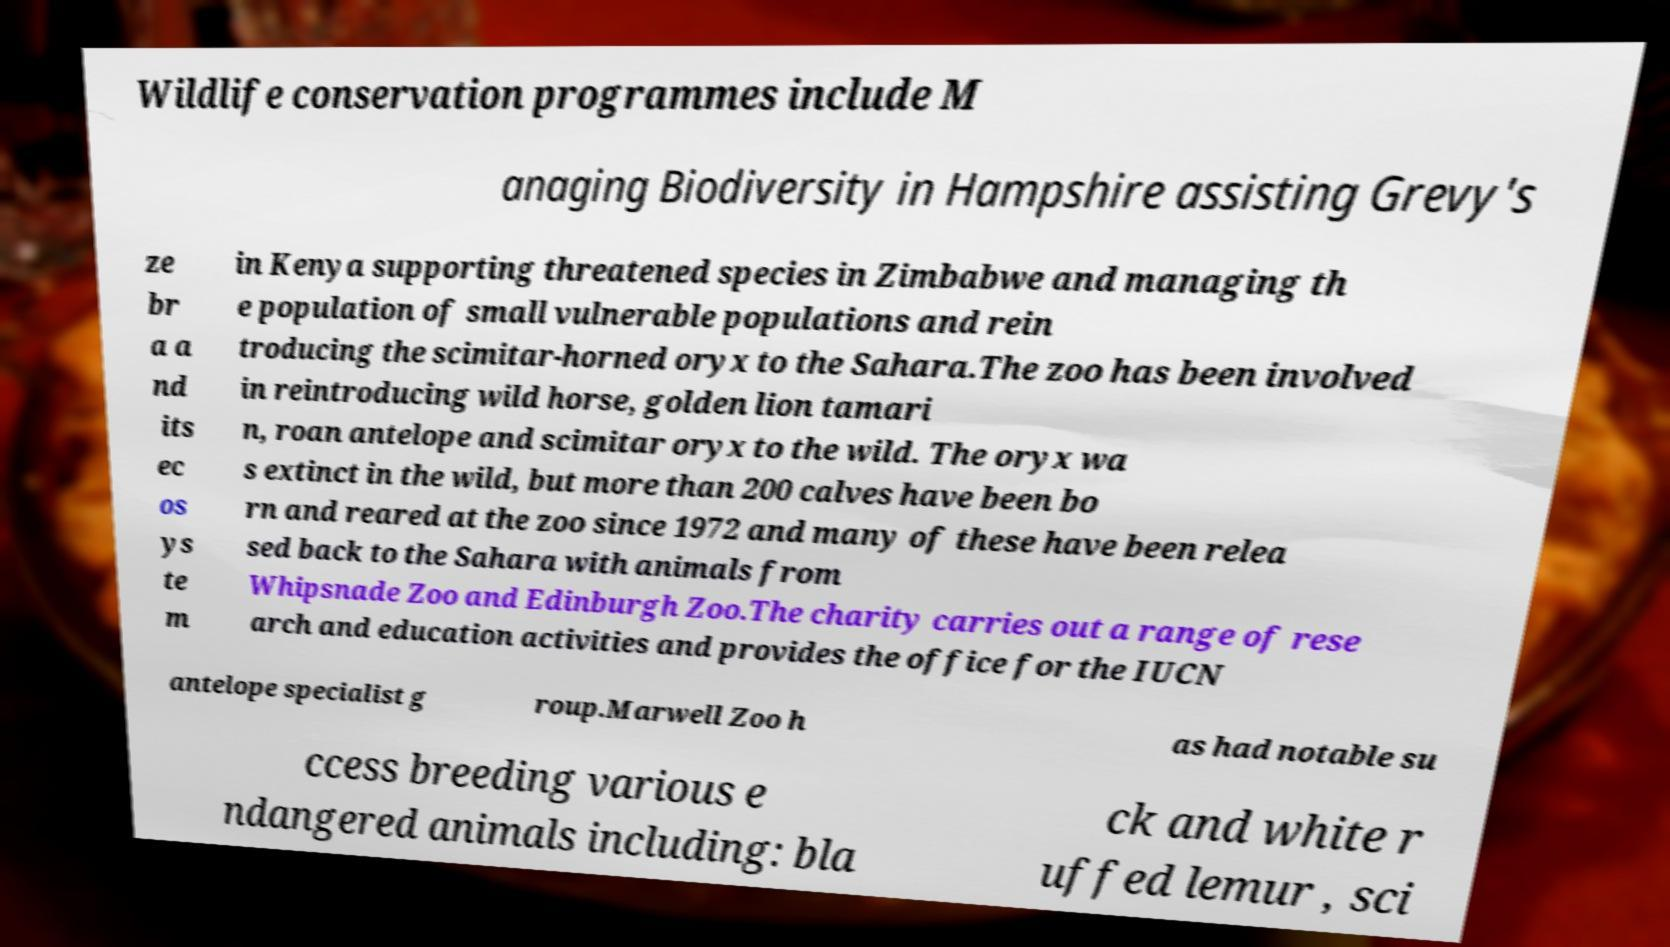Could you assist in decoding the text presented in this image and type it out clearly? Wildlife conservation programmes include M anaging Biodiversity in Hampshire assisting Grevy's ze br a a nd its ec os ys te m in Kenya supporting threatened species in Zimbabwe and managing th e population of small vulnerable populations and rein troducing the scimitar-horned oryx to the Sahara.The zoo has been involved in reintroducing wild horse, golden lion tamari n, roan antelope and scimitar oryx to the wild. The oryx wa s extinct in the wild, but more than 200 calves have been bo rn and reared at the zoo since 1972 and many of these have been relea sed back to the Sahara with animals from Whipsnade Zoo and Edinburgh Zoo.The charity carries out a range of rese arch and education activities and provides the office for the IUCN antelope specialist g roup.Marwell Zoo h as had notable su ccess breeding various e ndangered animals including: bla ck and white r uffed lemur , sci 